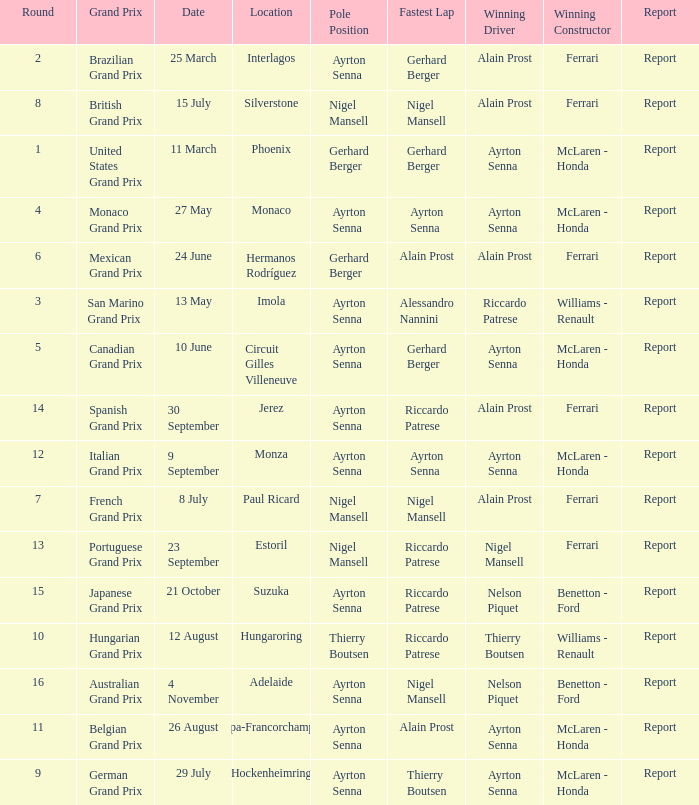Would you be able to parse every entry in this table? {'header': ['Round', 'Grand Prix', 'Date', 'Location', 'Pole Position', 'Fastest Lap', 'Winning Driver', 'Winning Constructor', 'Report'], 'rows': [['2', 'Brazilian Grand Prix', '25 March', 'Interlagos', 'Ayrton Senna', 'Gerhard Berger', 'Alain Prost', 'Ferrari', 'Report'], ['8', 'British Grand Prix', '15 July', 'Silverstone', 'Nigel Mansell', 'Nigel Mansell', 'Alain Prost', 'Ferrari', 'Report'], ['1', 'United States Grand Prix', '11 March', 'Phoenix', 'Gerhard Berger', 'Gerhard Berger', 'Ayrton Senna', 'McLaren - Honda', 'Report'], ['4', 'Monaco Grand Prix', '27 May', 'Monaco', 'Ayrton Senna', 'Ayrton Senna', 'Ayrton Senna', 'McLaren - Honda', 'Report'], ['6', 'Mexican Grand Prix', '24 June', 'Hermanos Rodríguez', 'Gerhard Berger', 'Alain Prost', 'Alain Prost', 'Ferrari', 'Report'], ['3', 'San Marino Grand Prix', '13 May', 'Imola', 'Ayrton Senna', 'Alessandro Nannini', 'Riccardo Patrese', 'Williams - Renault', 'Report'], ['5', 'Canadian Grand Prix', '10 June', 'Circuit Gilles Villeneuve', 'Ayrton Senna', 'Gerhard Berger', 'Ayrton Senna', 'McLaren - Honda', 'Report'], ['14', 'Spanish Grand Prix', '30 September', 'Jerez', 'Ayrton Senna', 'Riccardo Patrese', 'Alain Prost', 'Ferrari', 'Report'], ['12', 'Italian Grand Prix', '9 September', 'Monza', 'Ayrton Senna', 'Ayrton Senna', 'Ayrton Senna', 'McLaren - Honda', 'Report'], ['7', 'French Grand Prix', '8 July', 'Paul Ricard', 'Nigel Mansell', 'Nigel Mansell', 'Alain Prost', 'Ferrari', 'Report'], ['13', 'Portuguese Grand Prix', '23 September', 'Estoril', 'Nigel Mansell', 'Riccardo Patrese', 'Nigel Mansell', 'Ferrari', 'Report'], ['15', 'Japanese Grand Prix', '21 October', 'Suzuka', 'Ayrton Senna', 'Riccardo Patrese', 'Nelson Piquet', 'Benetton - Ford', 'Report'], ['10', 'Hungarian Grand Prix', '12 August', 'Hungaroring', 'Thierry Boutsen', 'Riccardo Patrese', 'Thierry Boutsen', 'Williams - Renault', 'Report'], ['16', 'Australian Grand Prix', '4 November', 'Adelaide', 'Ayrton Senna', 'Nigel Mansell', 'Nelson Piquet', 'Benetton - Ford', 'Report'], ['11', 'Belgian Grand Prix', '26 August', 'Spa-Francorchamps', 'Ayrton Senna', 'Alain Prost', 'Ayrton Senna', 'McLaren - Honda', 'Report'], ['9', 'German Grand Prix', '29 July', 'Hockenheimring', 'Ayrton Senna', 'Thierry Boutsen', 'Ayrton Senna', 'McLaren - Honda', 'Report']]} What is the date that Ayrton Senna was the drive in Monza? 9 September. 